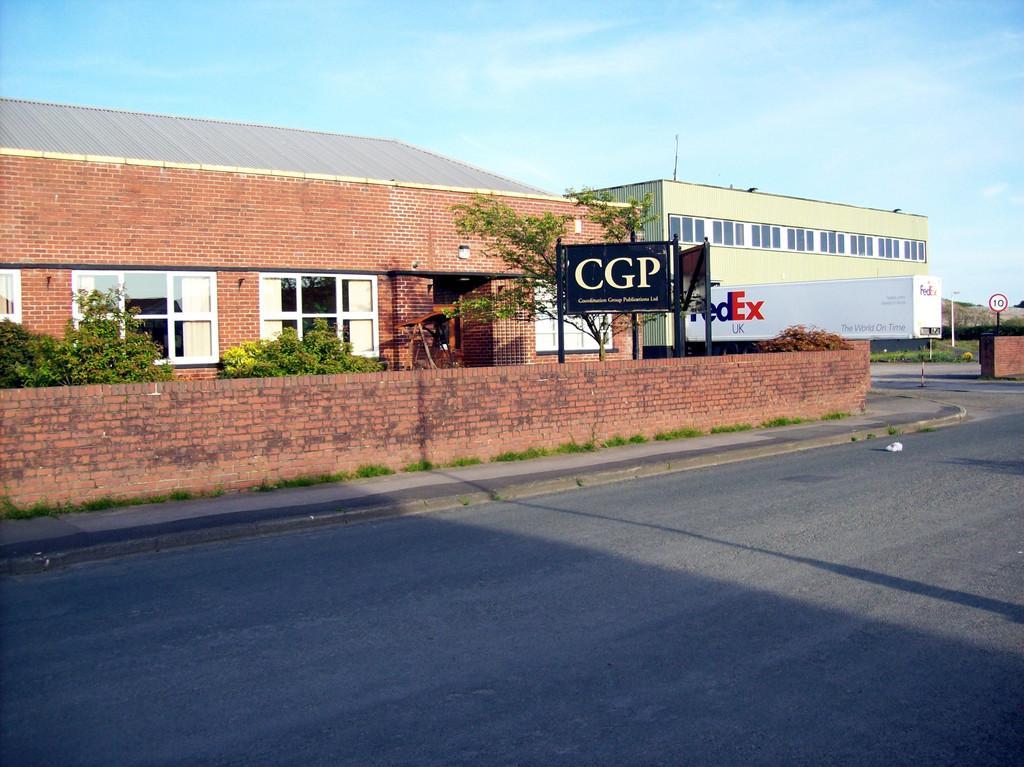Could you give a brief overview of what you see in this image? In this picture I can see buildings and few trees and couple of boards with some text on them and i can see a brick wall and a truck box with some text on it and i can see a caution board to the pole and a blue cloudy sky. 